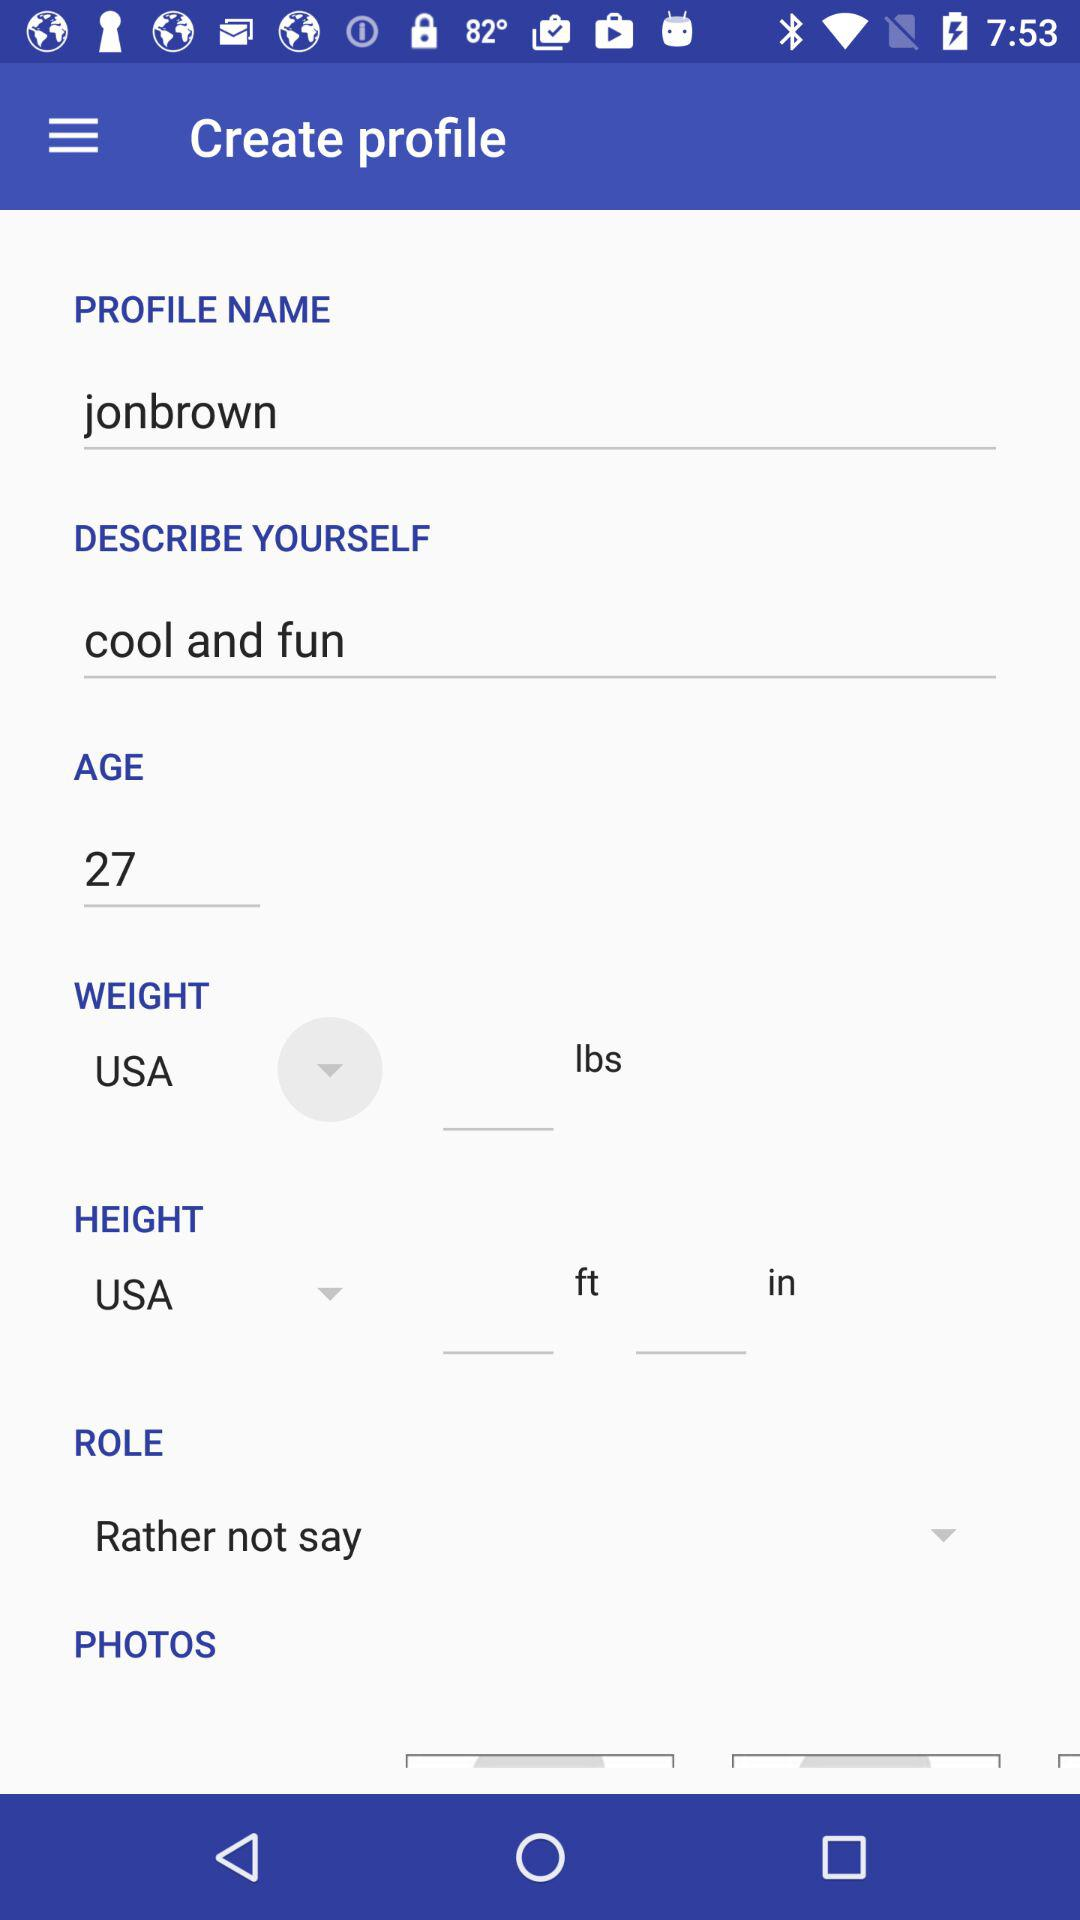What is the username? The username is "jonbrown". 